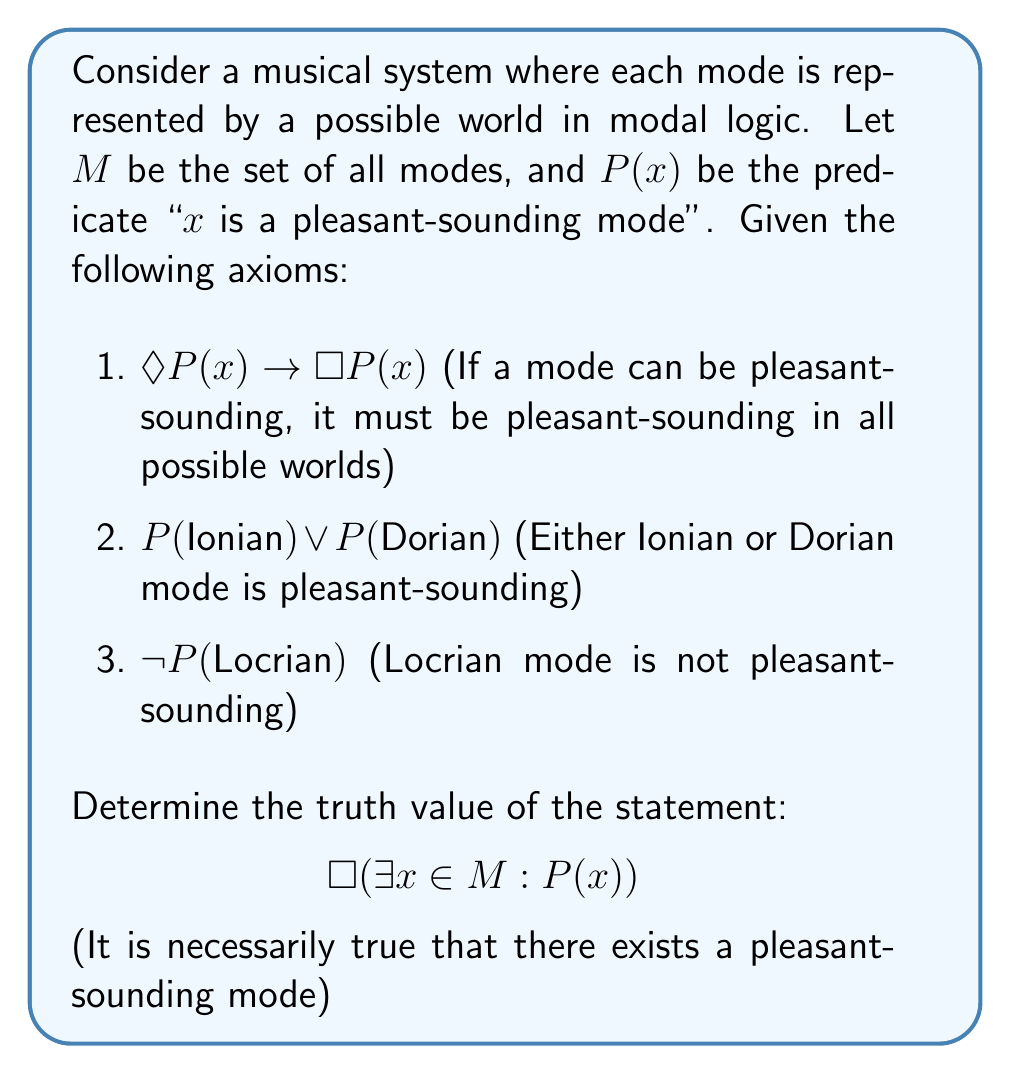Help me with this question. Let's approach this step-by-step using modal logic:

1) First, we need to understand what the statement $\Box(\exists x \in M : P(x))$ means. It asserts that in all possible worlds (or interpretations of our musical system), there exists at least one mode that is pleasant-sounding.

2) From axiom 2, we know that $P(\text{Ionian}) \lor P(\text{Dorian})$. This means that at least one of Ionian or Dorian is pleasant-sounding.

3) Let's consider the two possibilities:

   a) If $P(\text{Ionian})$ is true:
      By axiom 1, $\Diamond P(\text{Ionian}) \rightarrow \Box P(\text{Ionian})$
      Since $P(\text{Ionian})$ is true in this case, $\Diamond P(\text{Ionian})$ is also true.
      Therefore, $\Box P(\text{Ionian})$ must be true.

   b) If $P(\text{Dorian})$ is true:
      Similarly, by axiom 1, $\Diamond P(\text{Dorian}) \rightarrow \Box P(\text{Dorian})$
      Since $P(\text{Dorian})$ is true in this case, $\Diamond P(\text{Dorian})$ is also true.
      Therefore, $\Box P(\text{Dorian})$ must be true.

4) In both cases (a and b), we can conclude that there exists a mode that is necessarily pleasant-sounding in all possible worlds.

5) This means that regardless of which of Ionian or Dorian is pleasant-sounding (or if both are), there will always be at least one pleasant-sounding mode in all possible worlds.

6) Therefore, the statement $\Box(\exists x \in M : P(x))$ is true.

Note: Axiom 3 ($\neg P(\text{Locrian})$) is not directly relevant to proving this statement, but it reinforces the idea that not all modes are pleasant-sounding, making the question non-trivial.
Answer: True 